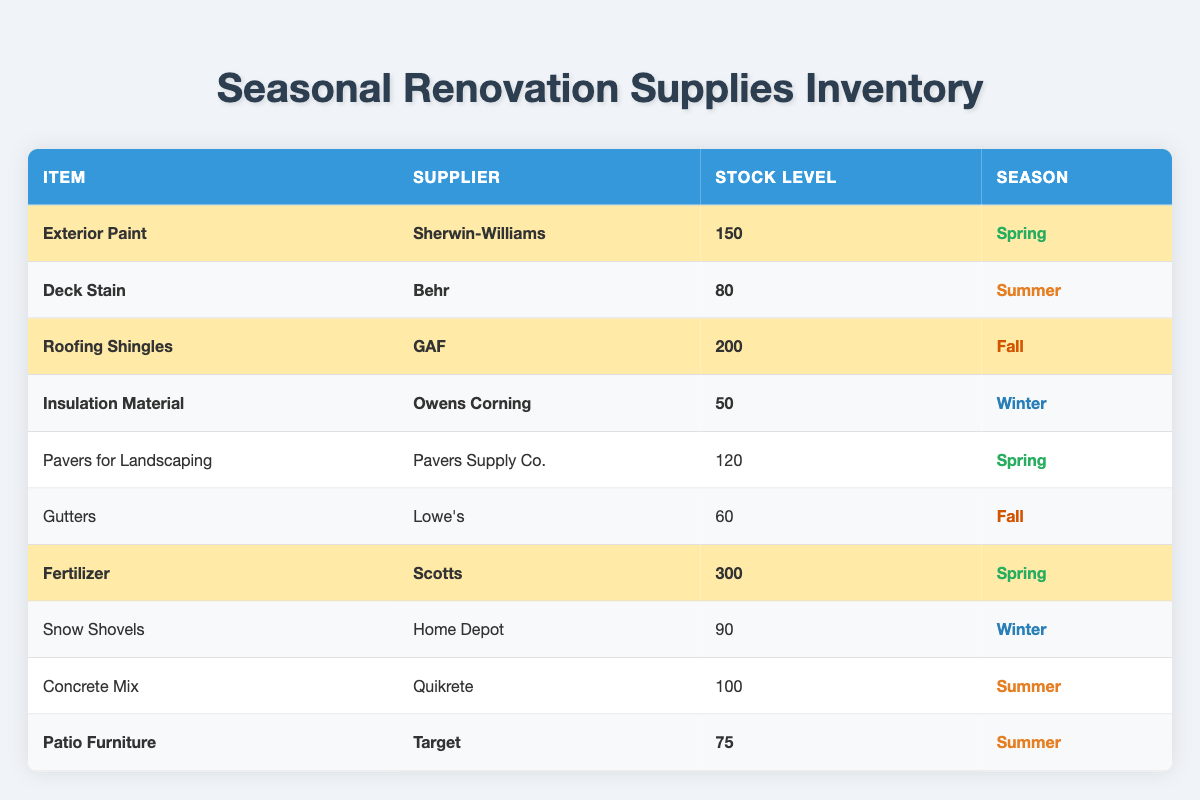What is the stock level of Exterior Paint? The stock level for Exterior Paint is listed directly in the table as 150.
Answer: 150 Which item has the highest stock level? By reviewing the stock levels for each item, Roofing Shingles has the highest stock level at 200.
Answer: Roofing Shingles How many high-demand items are there in the Spring season? The table shows three items in the Spring season: Exterior Paint, Fertilizer, and Pavers for Landscaping. Among these, only Exterior Paint and Fertilizer are labeled as high-demand. Therefore, there are two high-demand items.
Answer: 2 Is Gutters a high-demand item? The table lists Gutters without the high-demand highlight, indicating that it is not a high-demand item.
Answer: No What is the total stock level of high-demand items? The high-demand items are: Exterior Paint (150), Deck Stain (80), Roofing Shingles (200), Insulation Material (50), and Fertilizer (300). Adding these amounts gives: 150 + 80 + 200 + 50 + 300 = 780.
Answer: 780 Which season has the highest stock level of items? The highest stock level item is Roofing Shingles (200) in the Fall season, but Spring has more total stock when combining all items: Exterior Paint (150) + Fertilizer (300) + Pavers for Landscaping (120) = 570. So the total stock level in Fall is 200, Spring has 570 total.
Answer: Spring How many items have a stock level below 100? By examining the table, the items with stock levels below 100 are: Insulation Material (50), Gutters (60), Snow Shovels (90), and Patio Furniture (75). That's a total of four items.
Answer: 4 What percentage of items are in the Summer season? There are three items in the Summer season (Deck Stain, Concrete Mix, and Patio Furniture) out of a total of 10 items. To find the percentage, we calculate (3/10) * 100 = 30%.
Answer: 30% Which item has the lowest stock level? The item with the lowest stock level is Insulation Material, with a stock level of 50.
Answer: Insulation Material Are there more items classified as high-demand or low-demand? Counting the high-demand items: Exterior Paint, Deck Stain, Roofing Shingles, Insulation Material, Fertilizer, and Patio Furniture gives a total of 5 high-demand items. For low-demand: Pavers for Landscaping, Gutters, Concrete Mix, and Snow Shovels gives a total of 4 low-demand items. Therefore, there are more high-demand items.
Answer: High-demand items are more 